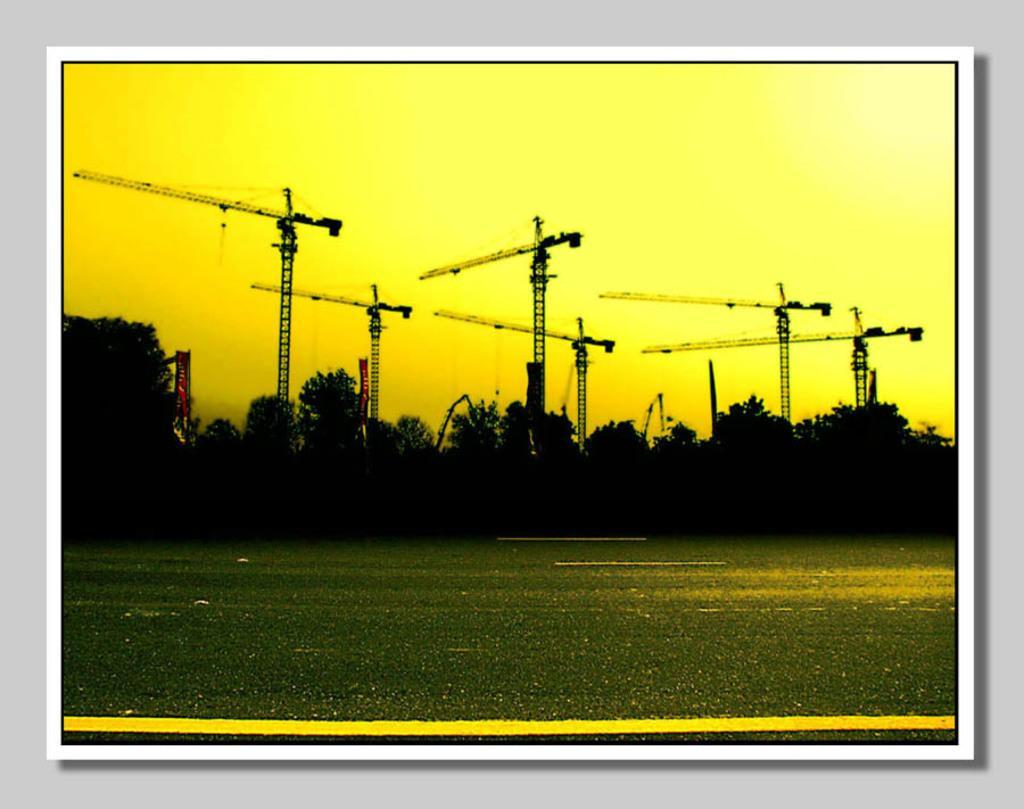Please provide a concise description of this image. In the picture I can see a road which has few trees beside it and there are few cranes in the background. 